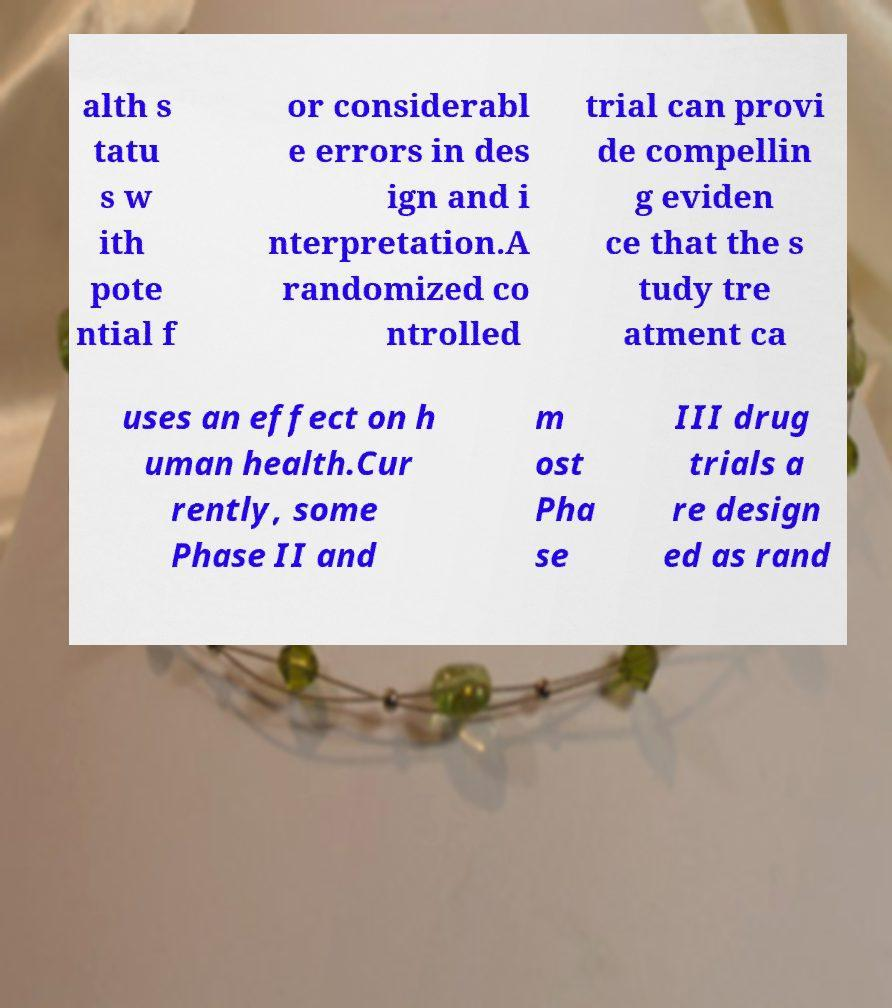I need the written content from this picture converted into text. Can you do that? alth s tatu s w ith pote ntial f or considerabl e errors in des ign and i nterpretation.A randomized co ntrolled trial can provi de compellin g eviden ce that the s tudy tre atment ca uses an effect on h uman health.Cur rently, some Phase II and m ost Pha se III drug trials a re design ed as rand 